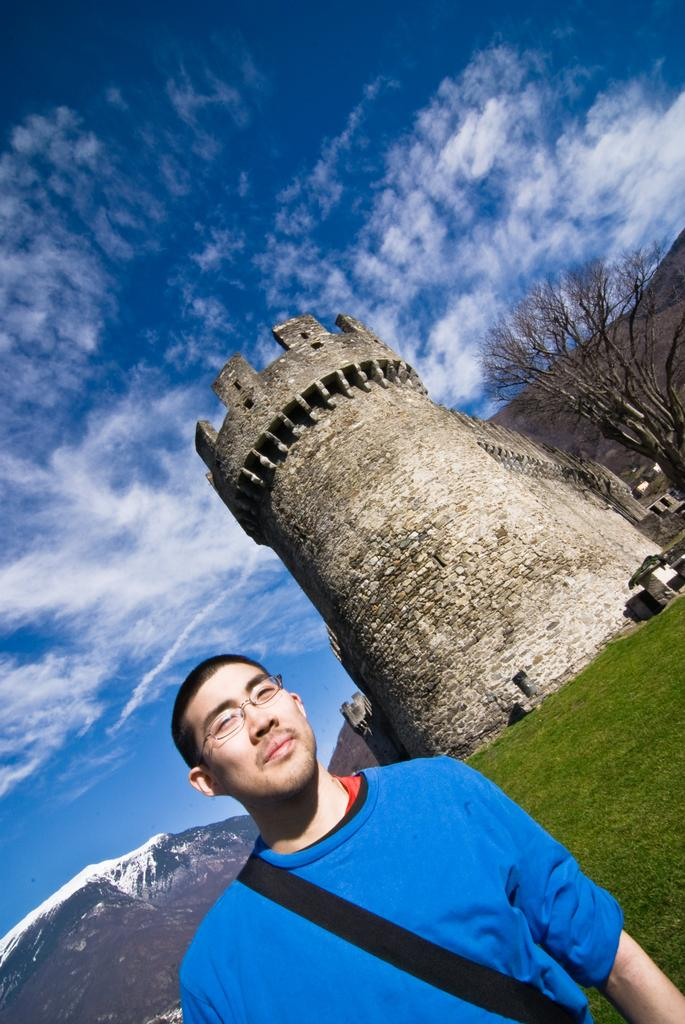What is the main subject in the foreground of the image? There is a man in the foreground of the image. What is the man wearing? The man is wearing a blue T-shirt. What accessory is the man carrying? The man is wearing a bag. What can be seen in the background of the image? There is a castle, grass, a tree, mountains, and the sky visible in the background of the image. Can you describe the sky in the image? The sky is visible in the background of the image, and there is a cloud present. What type of stem can be seen growing from the man's T-shirt in the image? There is no stem growing from the man's T-shirt in the image. How does the man's journey progress in the image? The image does not depict a journey, so it cannot be determined how the man's journey progresses. 